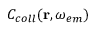<formula> <loc_0><loc_0><loc_500><loc_500>C _ { c o l l } ( r , \omega _ { e m } )</formula> 